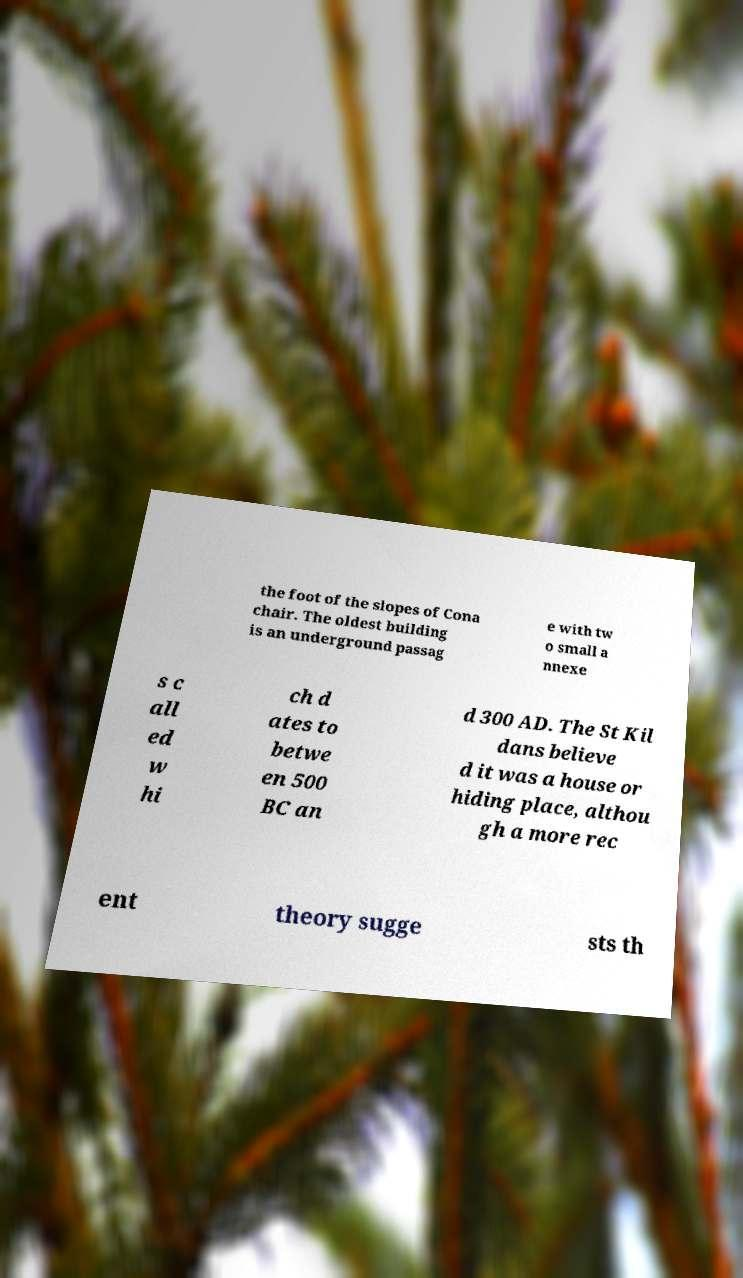For documentation purposes, I need the text within this image transcribed. Could you provide that? the foot of the slopes of Cona chair. The oldest building is an underground passag e with tw o small a nnexe s c all ed w hi ch d ates to betwe en 500 BC an d 300 AD. The St Kil dans believe d it was a house or hiding place, althou gh a more rec ent theory sugge sts th 